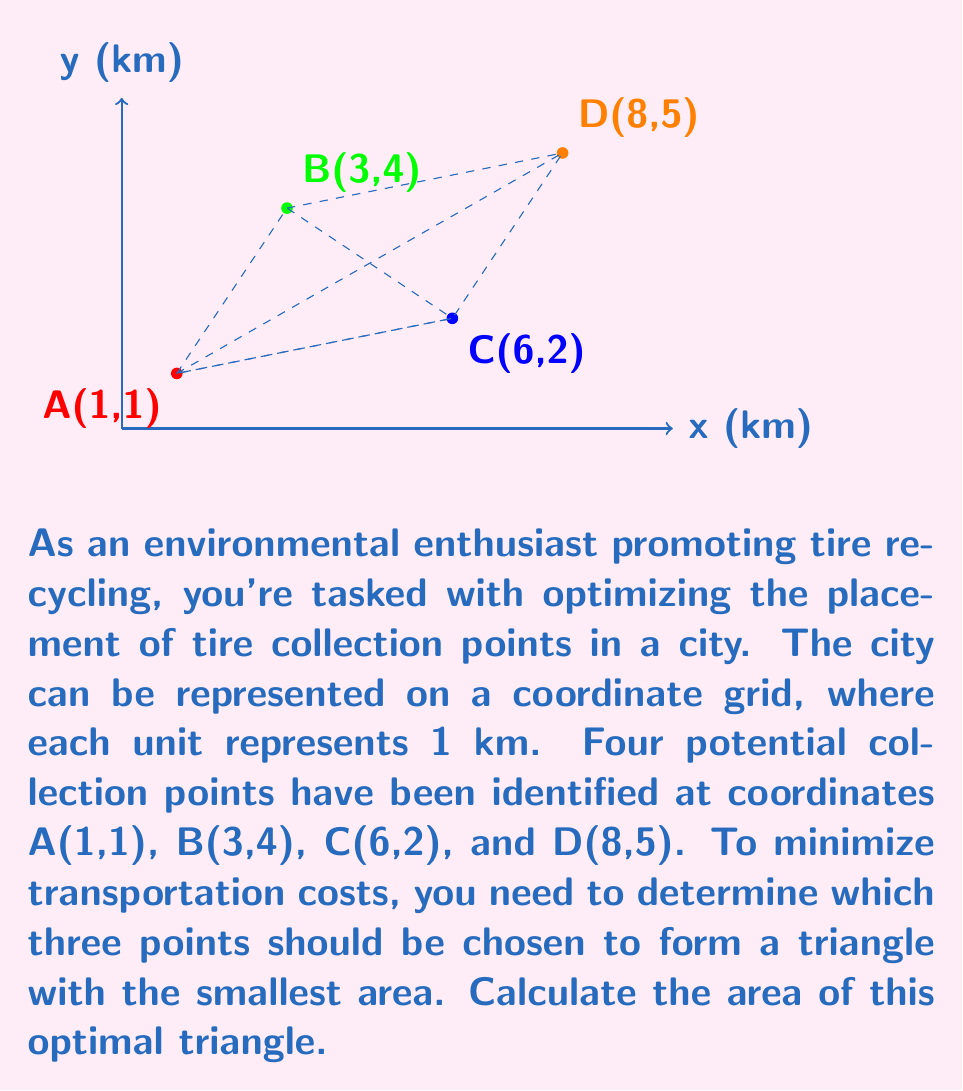Solve this math problem. To solve this problem, we need to calculate the areas of all possible triangles formed by three of the four points and find the smallest one. We can use the formula for the area of a triangle given the coordinates of its vertices:

$$ \text{Area} = \frac{1}{2}|x_1(y_2 - y_3) + x_2(y_3 - y_1) + x_3(y_1 - y_2)| $$

Let's calculate the areas for all four possible triangles:

1. Triangle ABC:
   $$ \text{Area}_{\text{ABC}} = \frac{1}{2}|1(4 - 2) + 3(2 - 1) + 6(1 - 4)| = \frac{1}{2}|2 + 3 - 18| = 6.5 \text{ km}^2 $$

2. Triangle ABD:
   $$ \text{Area}_{\text{ABD}} = \frac{1}{2}|1(4 - 5) + 3(5 - 1) + 8(1 - 4)| = \frac{1}{2}|-1 + 12 - 24| = 6.5 \text{ km}^2 $$

3. Triangle ACD:
   $$ \text{Area}_{\text{ACD}} = \frac{1}{2}|1(2 - 5) + 6(5 - 1) + 8(1 - 2)| = \frac{1}{2}|-3 + 24 - 8| = 6.5 \text{ km}^2 $$

4. Triangle BCD:
   $$ \text{Area}_{\text{BCD}} = \frac{1}{2}|3(2 - 5) + 6(5 - 4) + 8(4 - 2)| = \frac{1}{2}|-9 + 6 + 16| = 6.5 \text{ km}^2 $$

Surprisingly, all four triangles have the same area of 6.5 km². This means that any three points can be chosen to form the optimal triangle for tire collection points.
Answer: 6.5 km² 